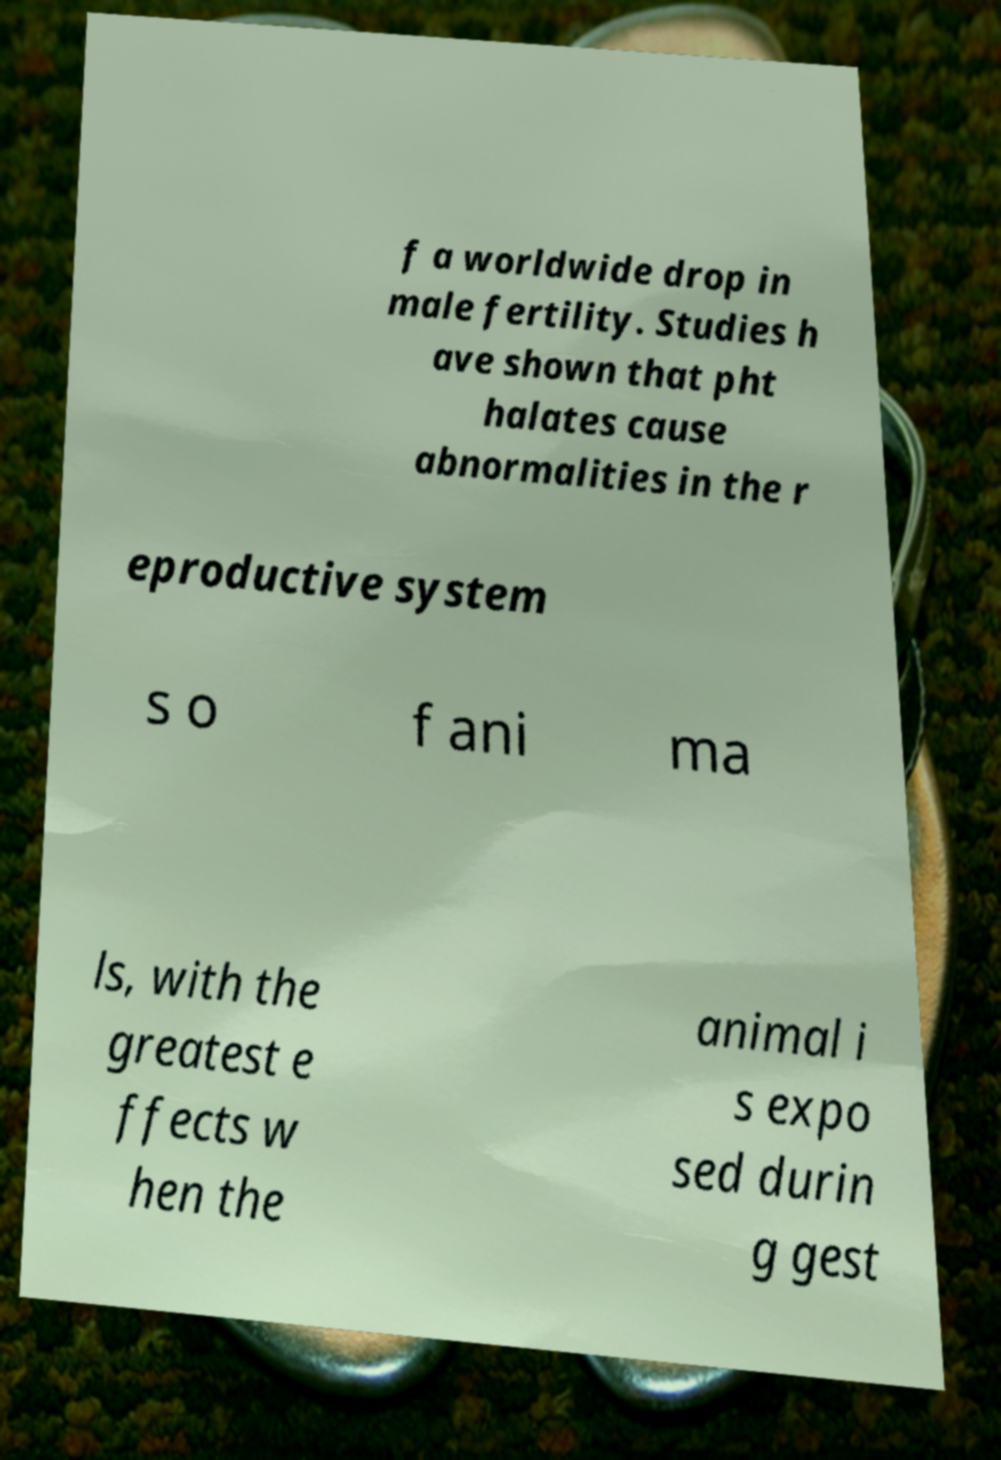I need the written content from this picture converted into text. Can you do that? f a worldwide drop in male fertility. Studies h ave shown that pht halates cause abnormalities in the r eproductive system s o f ani ma ls, with the greatest e ffects w hen the animal i s expo sed durin g gest 